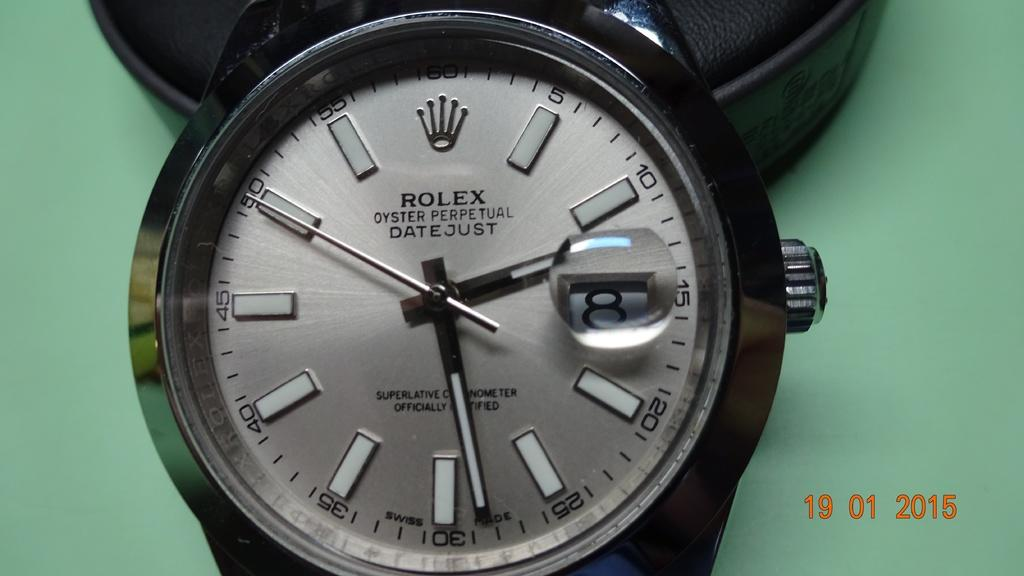Provide a one-sentence caption for the provided image. A Rolex watch is sitting on a green background. 